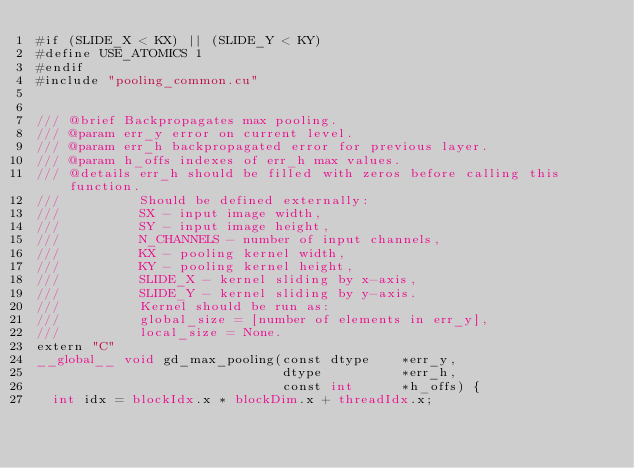<code> <loc_0><loc_0><loc_500><loc_500><_Cuda_>#if (SLIDE_X < KX) || (SLIDE_Y < KY)
#define USE_ATOMICS 1
#endif
#include "pooling_common.cu"


/// @brief Backpropagates max pooling.
/// @param err_y error on current level.
/// @param err_h backpropagated error for previous layer.
/// @param h_offs indexes of err_h max values.
/// @details err_h should be filled with zeros before calling this function.
///          Should be defined externally:
///          SX - input image width,
///          SY - input image height,
///          N_CHANNELS - number of input channels,
///          KX - pooling kernel width,
///          KY - pooling kernel height,
///          SLIDE_X - kernel sliding by x-axis,
///          SLIDE_Y - kernel sliding by y-axis.
///          Kernel should be run as:
///          global_size = [number of elements in err_y],
///          local_size = None.
extern "C"
__global__ void gd_max_pooling(const dtype    *err_y,
                               dtype          *err_h,
                               const int      *h_offs) {
  int idx = blockIdx.x * blockDim.x + threadIdx.x;</code> 